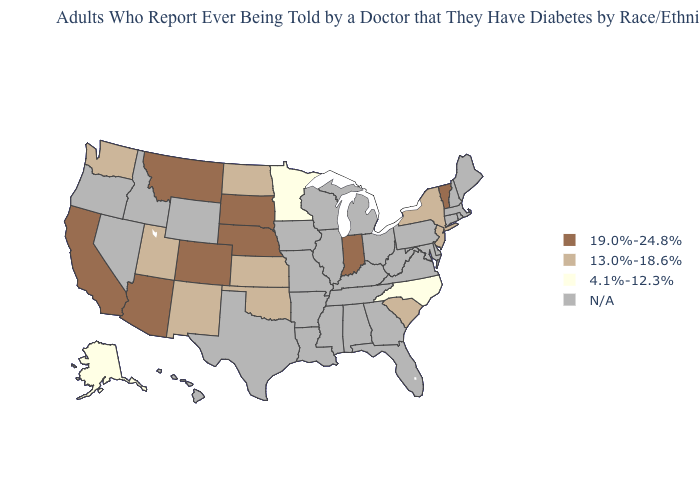Which states hav the highest value in the Northeast?
Answer briefly. Vermont. Name the states that have a value in the range 13.0%-18.6%?
Be succinct. Kansas, New Jersey, New Mexico, New York, North Dakota, Oklahoma, South Carolina, Utah, Washington. Does the map have missing data?
Be succinct. Yes. Among the states that border Oklahoma , which have the highest value?
Be succinct. Colorado. Does South Dakota have the highest value in the USA?
Answer briefly. Yes. What is the value of Nebraska?
Quick response, please. 19.0%-24.8%. Name the states that have a value in the range N/A?
Keep it brief. Alabama, Arkansas, Connecticut, Delaware, Florida, Georgia, Hawaii, Idaho, Illinois, Iowa, Kentucky, Louisiana, Maine, Maryland, Massachusetts, Michigan, Mississippi, Missouri, Nevada, New Hampshire, Ohio, Oregon, Pennsylvania, Rhode Island, Tennessee, Texas, Virginia, West Virginia, Wisconsin, Wyoming. What is the value of South Carolina?
Write a very short answer. 13.0%-18.6%. What is the value of Virginia?
Be succinct. N/A. How many symbols are there in the legend?
Keep it brief. 4. How many symbols are there in the legend?
Keep it brief. 4. Name the states that have a value in the range 19.0%-24.8%?
Short answer required. Arizona, California, Colorado, Indiana, Montana, Nebraska, South Dakota, Vermont. What is the value of New Hampshire?
Give a very brief answer. N/A. 